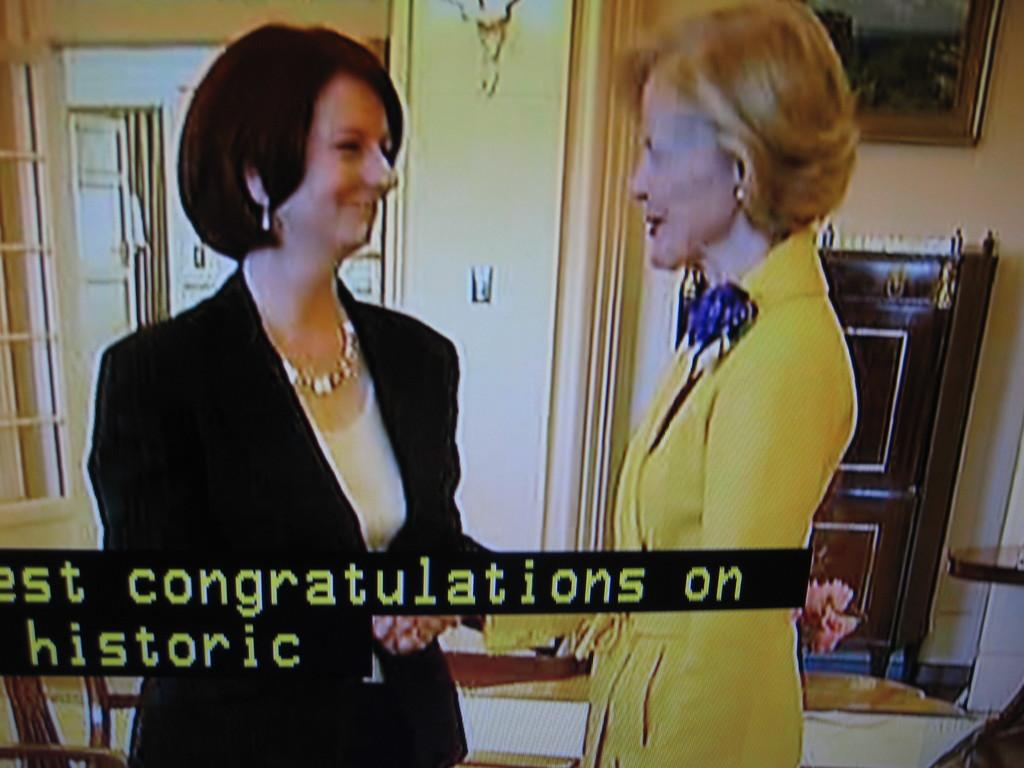How many people are present in the image? There are two people standing in the image. What colors are featured in the dresses worn by the people? The people are wearing white, yellow, and black color dresses. What can be seen in the background of the image? There is a window visible in the background, along with other objects. What is attached to the wall in the image? A frame is attached to the wall. Is the woman in the image holding a cherry? There is no woman or cherry present in the image. Who is the father of the people in the image? The provided facts do not mention any familial relationships between the people in the image, so it cannot be determined who their father is. 